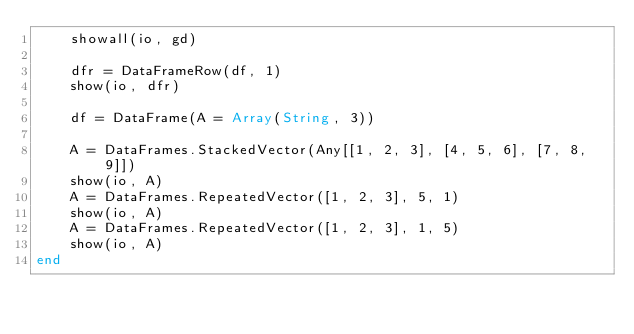<code> <loc_0><loc_0><loc_500><loc_500><_Julia_>    showall(io, gd)

    dfr = DataFrameRow(df, 1)
    show(io, dfr)

    df = DataFrame(A = Array(String, 3))

    A = DataFrames.StackedVector(Any[[1, 2, 3], [4, 5, 6], [7, 8, 9]])
    show(io, A)
    A = DataFrames.RepeatedVector([1, 2, 3], 5, 1)
    show(io, A)
    A = DataFrames.RepeatedVector([1, 2, 3], 1, 5)
    show(io, A)
end
</code> 